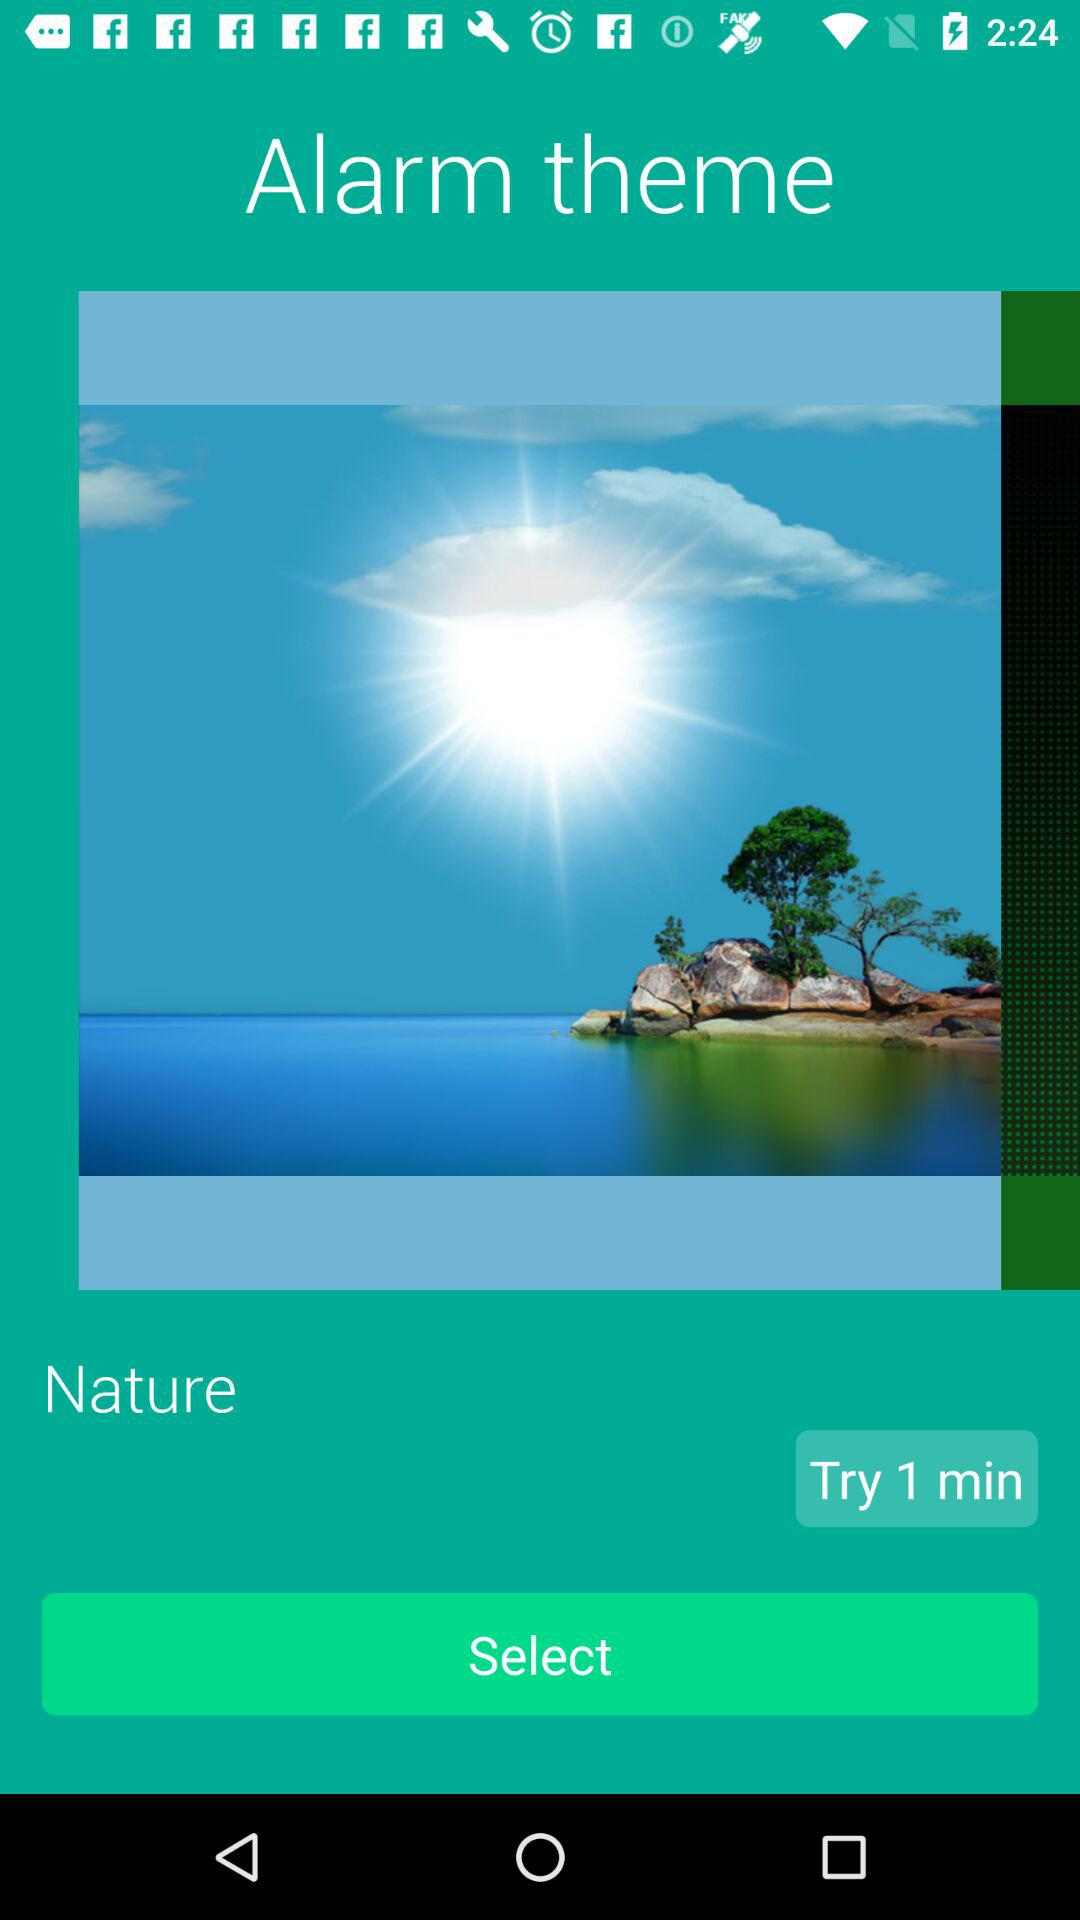What is the duration to try the theme? The duration to try the theme is 1 minute. 